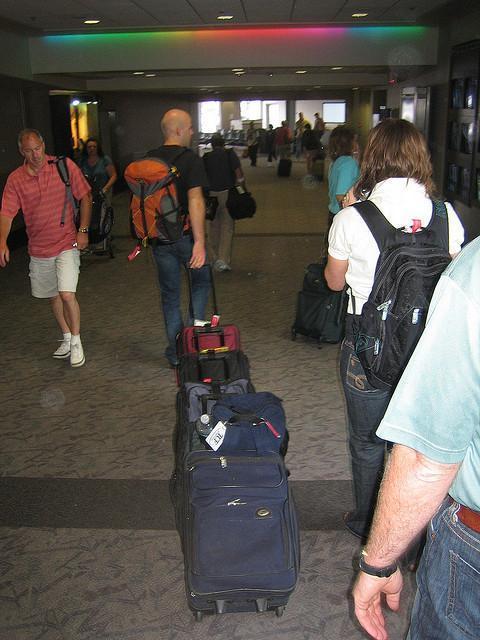How many people can you see?
Give a very brief answer. 7. How many backpacks are visible?
Give a very brief answer. 4. How many suitcases can be seen?
Give a very brief answer. 4. 